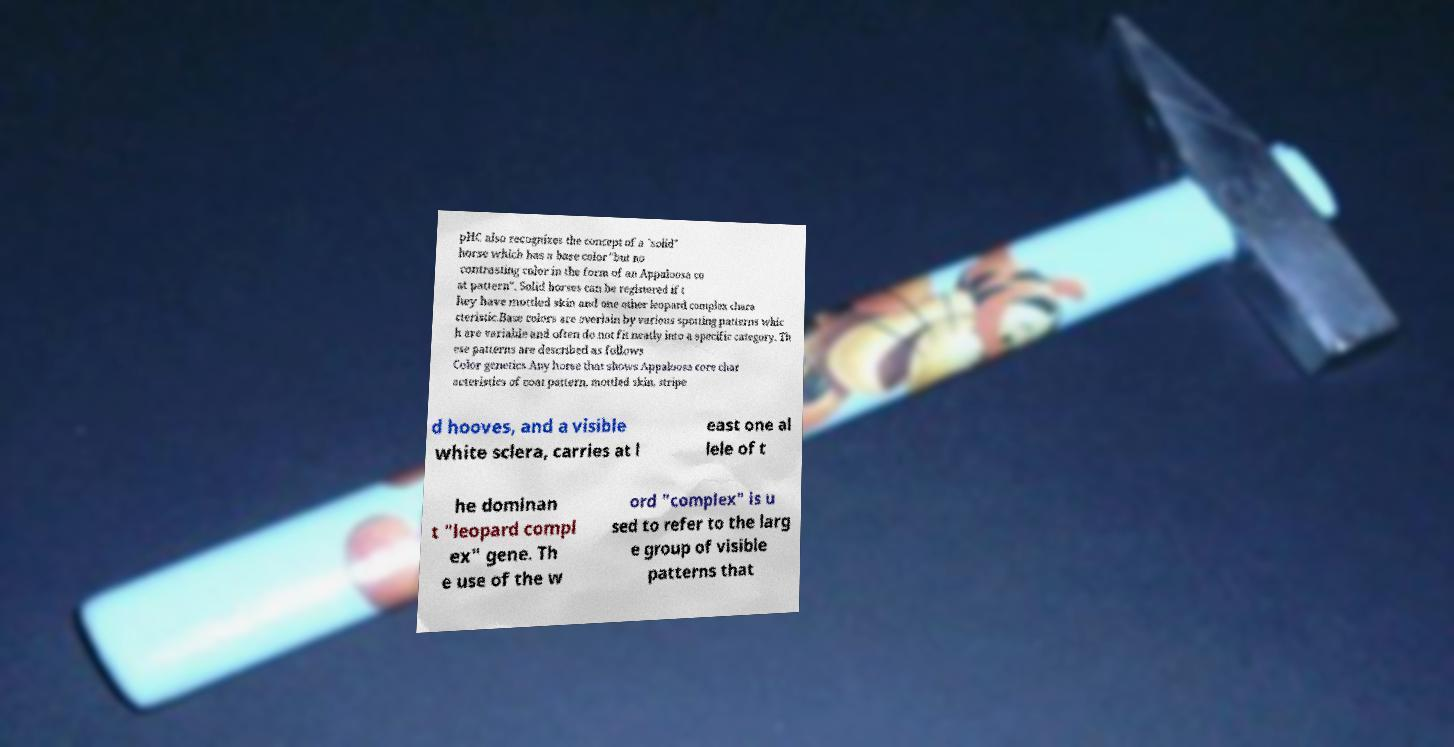Please read and relay the text visible in this image. What does it say? pHC also recognizes the concept of a "solid" horse which has a base color "but no contrasting color in the form of an Appaloosa co at pattern". Solid horses can be registered if t hey have mottled skin and one other leopard complex chara cteristic.Base colors are overlain by various spotting patterns whic h are variable and often do not fit neatly into a specific category. Th ese patterns are described as follows Color genetics.Any horse that shows Appaloosa core char acteristics of coat pattern, mottled skin, stripe d hooves, and a visible white sclera, carries at l east one al lele of t he dominan t "leopard compl ex" gene. Th e use of the w ord "complex" is u sed to refer to the larg e group of visible patterns that 